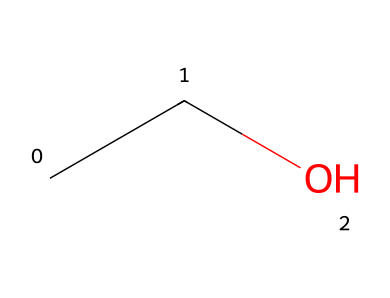What is the name of this chemical? The SMILES representation "CCO" corresponds to ethanol, which is a common simple alcohol. The presence of "C" indicates carbon atoms and the "O" indicates an oxygen atom typically associated with alcohols.
Answer: ethanol How many carbon atoms are in the molecule? The SMILES shows two "C" characters in the string "CCO," indicating there are two carbon atoms present in the ethanol molecule.
Answer: 2 How many hydrogen atoms are bonded to the carbon atoms in ethanol? In the structure of ethanol, each carbon typically forms four bonds. The first carbon is bonded to another carbon and three hydrogens, while the second carbon is bonded to the first carbon and one hydrogen (and the hydroxyl group). Therefore, the total number of hydrogen atoms is five.
Answer: 6 What functional group is present in this molecule? The "O" in the SMILES notation signifies the presence of a hydroxyl (-OH) group, which is characteristic of alcohols. The structure clearly shows that ethanol is an alcohol due to this functional group.
Answer: hydroxyl Why is ethanol used as a hand sanitizer ingredient? Ethanol is an effective antimicrobial agent that denatures proteins and dissolves lipids, disrupting cell membranes of bacteria and viruses. This property is critical for its use in sanitizers. The molecular structure involving the hydroxyl group enhances its solvency in water and effectiveness in these roles.
Answer: antimicrobial Is ethanol a polar or non-polar solvent? Ethanol contains a hydroxyl group (-OH) which makes it polar due to the electronegativity difference between oxygen and hydrogen. The overall structure, with both polar and non-polar characteristics, contributes to its property as a polar solvent.
Answer: polar 